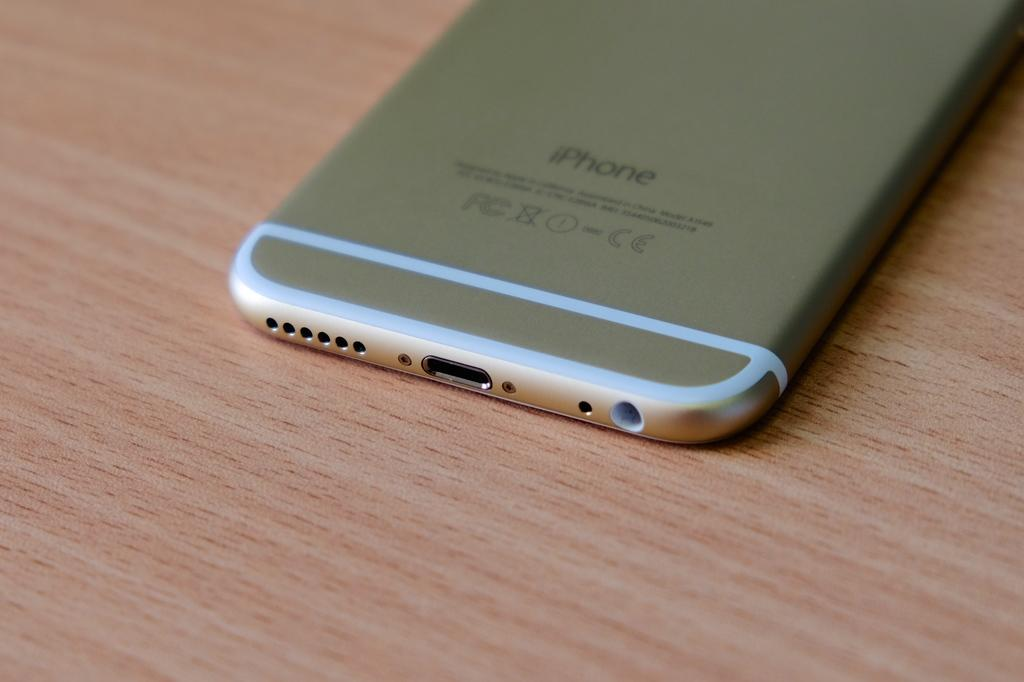<image>
Provide a brief description of the given image. A silver iPhone lies face down on a wooden surface. 